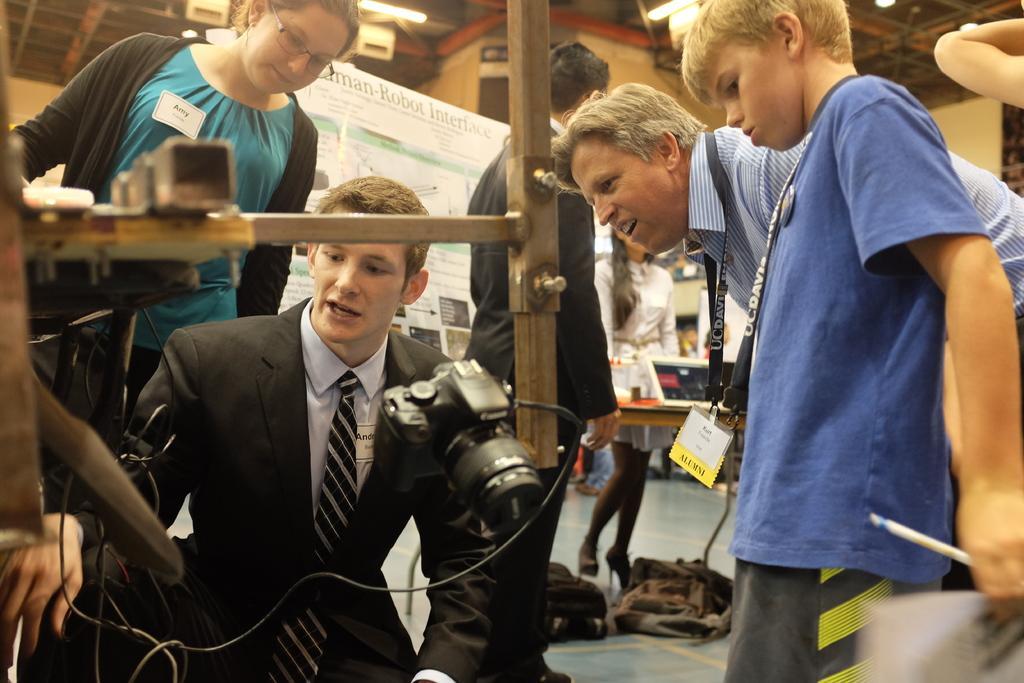Please provide a concise description of this image. This picture describes about group of people, few people wore tags, in the middle of the image we can see a camera, in the background we can find baggage, few lights and a hoarding. 